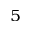<formula> <loc_0><loc_0><loc_500><loc_500>_ { 5 }</formula> 